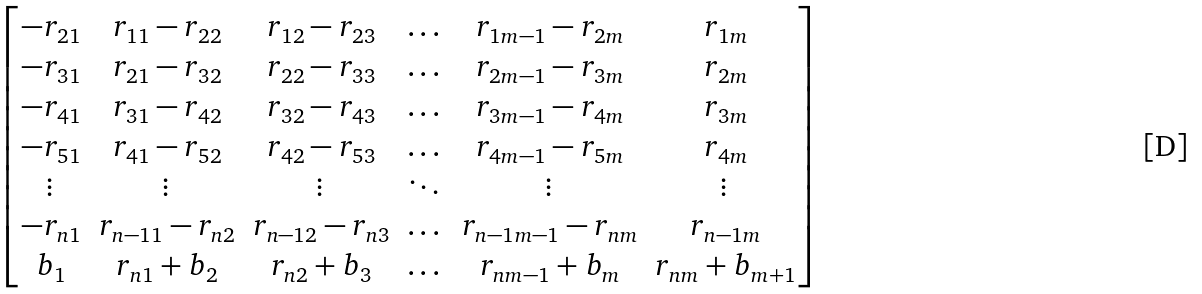<formula> <loc_0><loc_0><loc_500><loc_500>\begin{bmatrix} - r _ { 2 1 } & r _ { 1 1 } - r _ { 2 2 } & r _ { 1 2 } - r _ { 2 3 } & \dots & r _ { 1 m - 1 } - r _ { 2 m } & r _ { 1 m } \\ - r _ { 3 1 } & r _ { 2 1 } - r _ { 3 2 } & r _ { 2 2 } - r _ { 3 3 } & \dots & r _ { 2 m - 1 } - r _ { 3 m } & r _ { 2 m } \\ - r _ { 4 1 } & r _ { 3 1 } - r _ { 4 2 } & r _ { 3 2 } - r _ { 4 3 } & \dots & r _ { 3 m - 1 } - r _ { 4 m } & r _ { 3 m } \\ - r _ { 5 1 } & r _ { 4 1 } - r _ { 5 2 } & r _ { 4 2 } - r _ { 5 3 } & \dots & r _ { 4 m - 1 } - r _ { 5 m } & r _ { 4 m } \\ \vdots & \vdots & \vdots & \ddots & \vdots & \vdots \\ - r _ { n 1 } & r _ { n - 1 1 } - r _ { n 2 } & r _ { n - 1 2 } - r _ { n 3 } & \dots & r _ { n - 1 m - 1 } - r _ { n m } & r _ { n - 1 m } \\ b _ { 1 } & r _ { n 1 } + b _ { 2 } & r _ { n 2 } + b _ { 3 } & \dots & r _ { n m - 1 } + b _ { m } & r _ { n m } + b _ { m + 1 } \\ \end{bmatrix}</formula> 